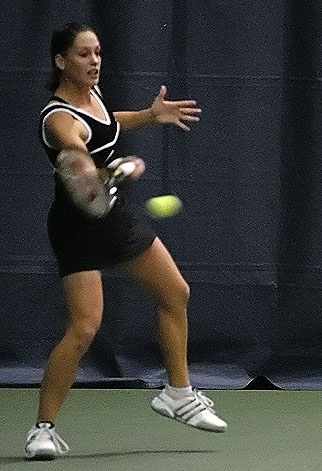Describe the objects in this image and their specific colors. I can see people in black, maroon, and gray tones, tennis racket in black and gray tones, and sports ball in black, olive, khaki, and darkgreen tones in this image. 